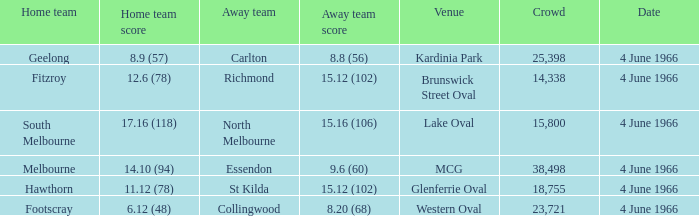6 (60)? 38498.0. 